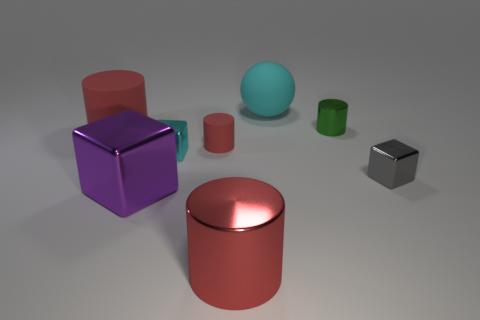How many red cylinders must be subtracted to get 1 red cylinders? 2 Subtract 2 cylinders. How many cylinders are left? 2 Subtract all gray cubes. How many cubes are left? 2 Subtract all red cylinders. How many cylinders are left? 1 Subtract 1 cyan spheres. How many objects are left? 7 Subtract all balls. How many objects are left? 7 Subtract all gray spheres. Subtract all brown cubes. How many spheres are left? 1 Subtract all brown cylinders. How many blue cubes are left? 0 Subtract all big rubber things. Subtract all purple objects. How many objects are left? 5 Add 4 cyan blocks. How many cyan blocks are left? 5 